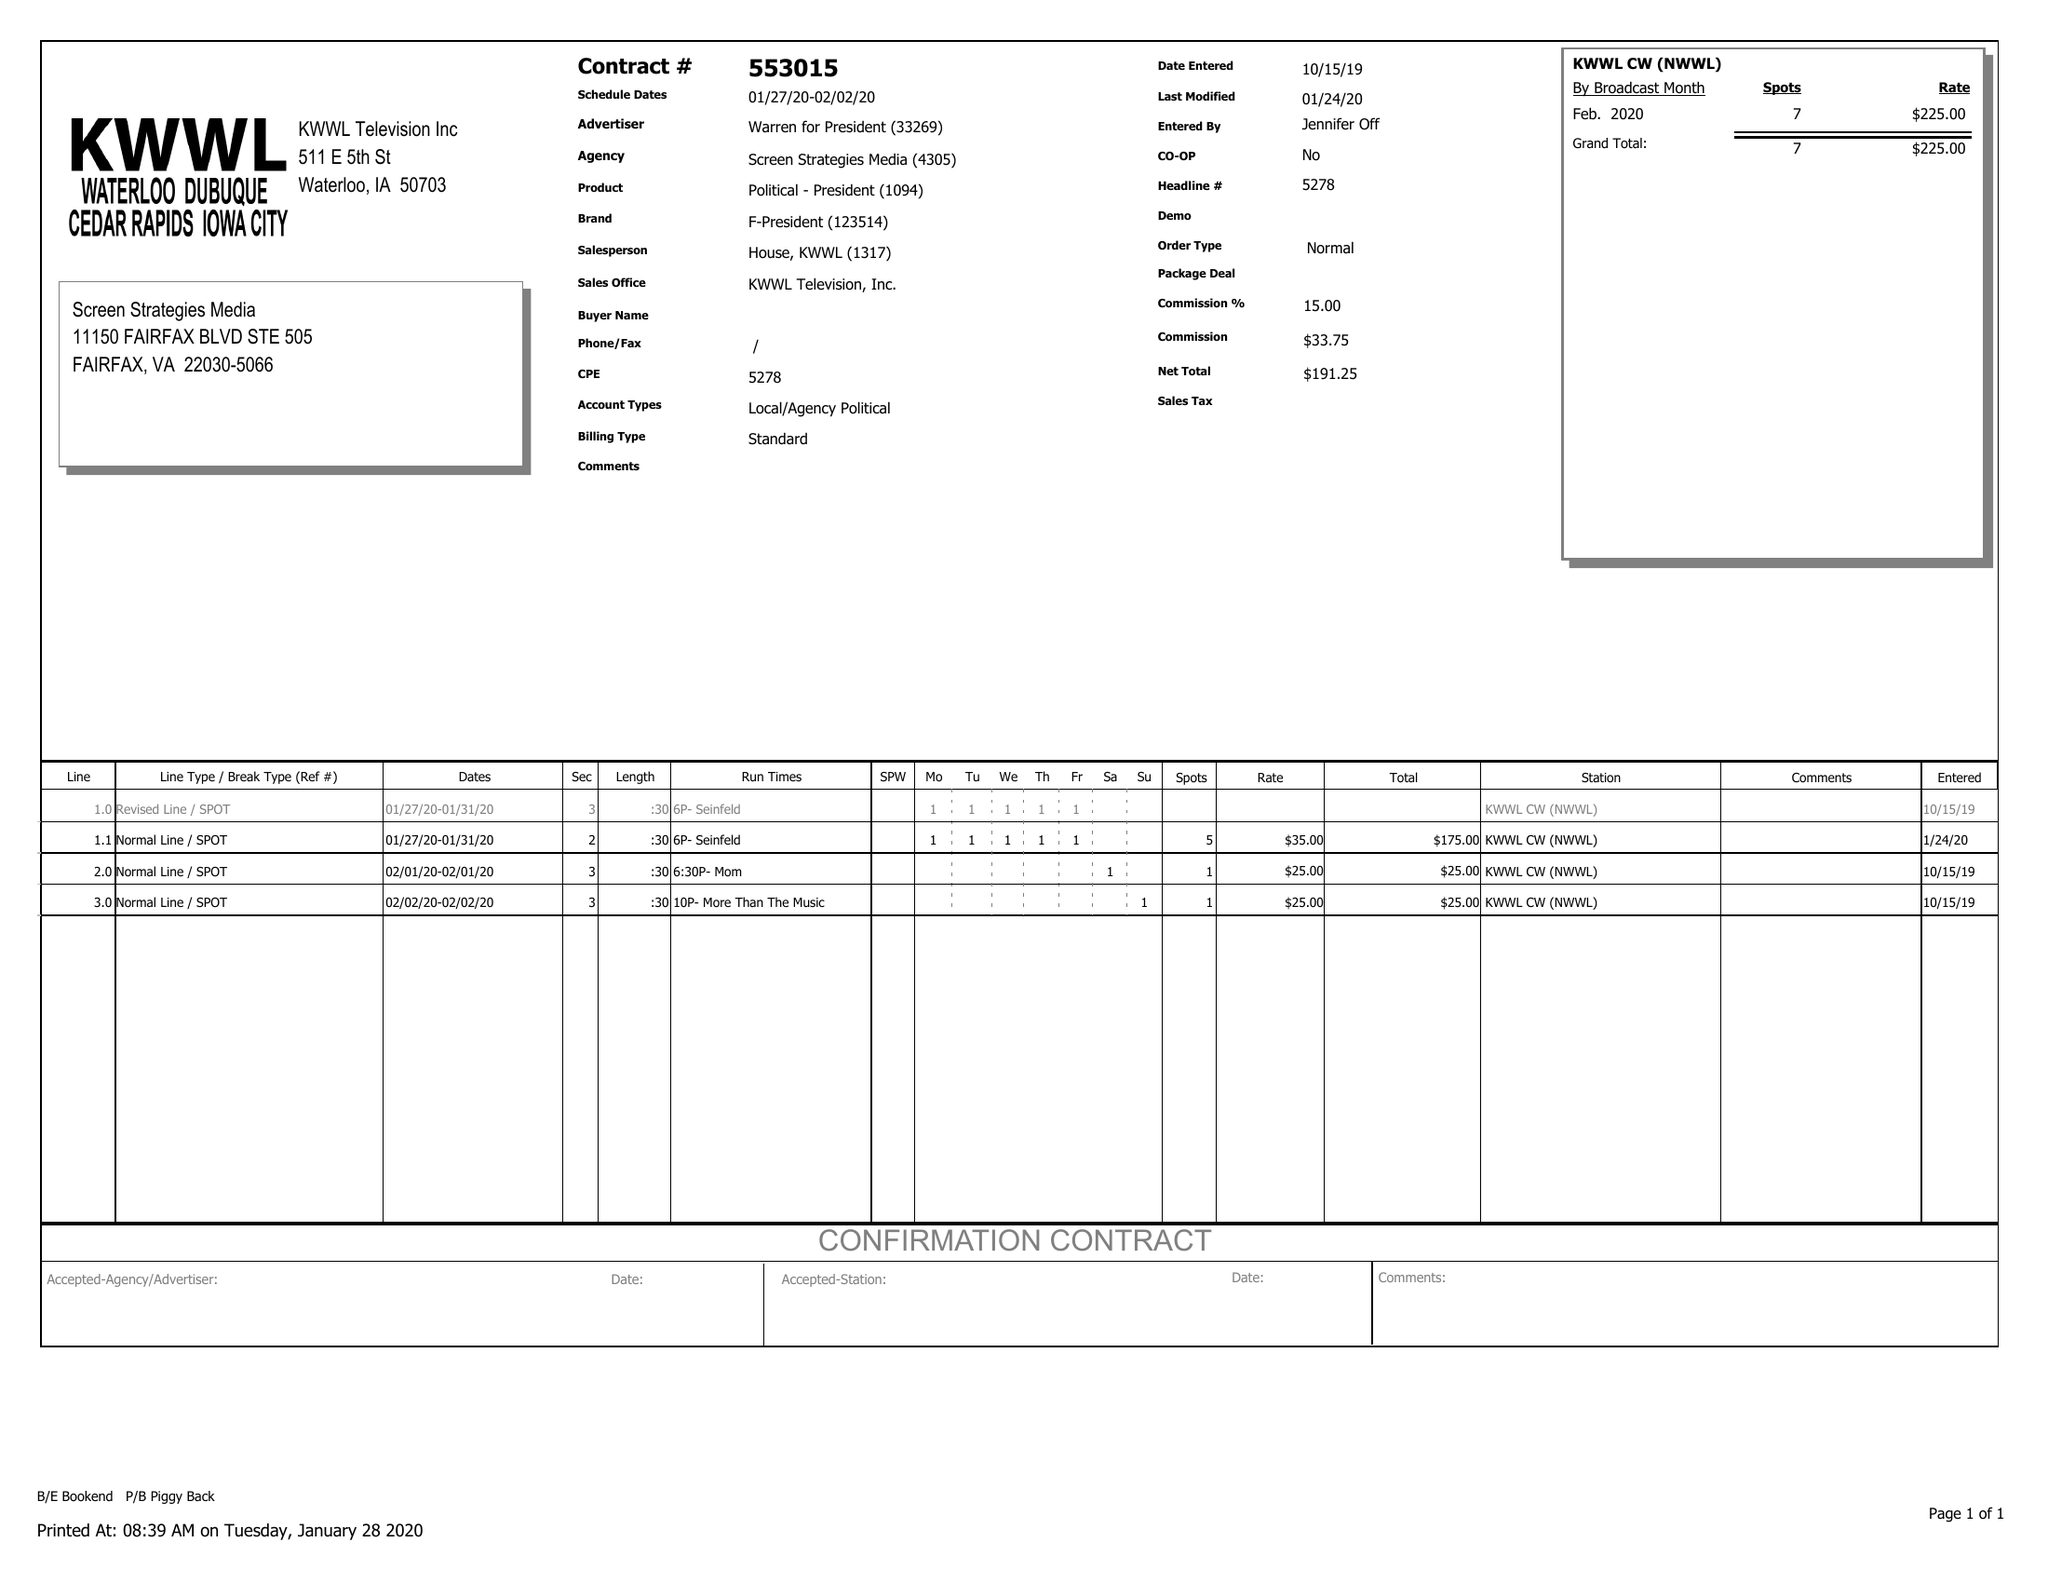What is the value for the flight_from?
Answer the question using a single word or phrase. 01/27/20 